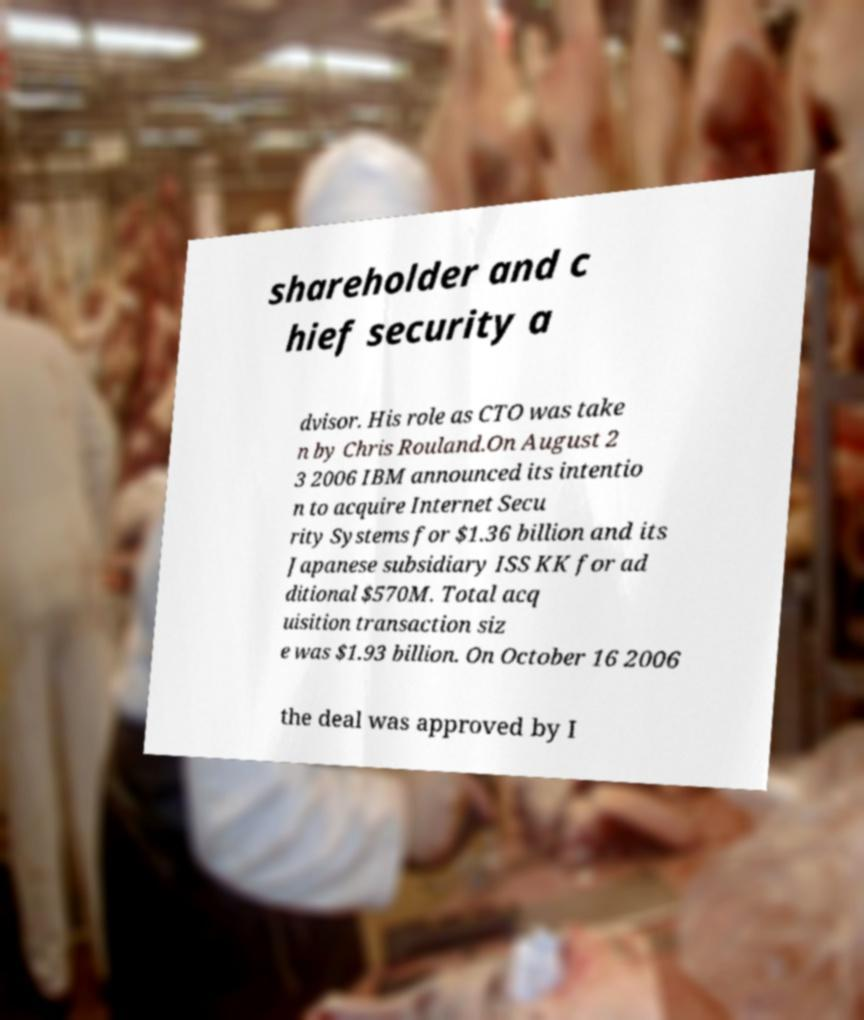There's text embedded in this image that I need extracted. Can you transcribe it verbatim? shareholder and c hief security a dvisor. His role as CTO was take n by Chris Rouland.On August 2 3 2006 IBM announced its intentio n to acquire Internet Secu rity Systems for $1.36 billion and its Japanese subsidiary ISS KK for ad ditional $570M. Total acq uisition transaction siz e was $1.93 billion. On October 16 2006 the deal was approved by I 